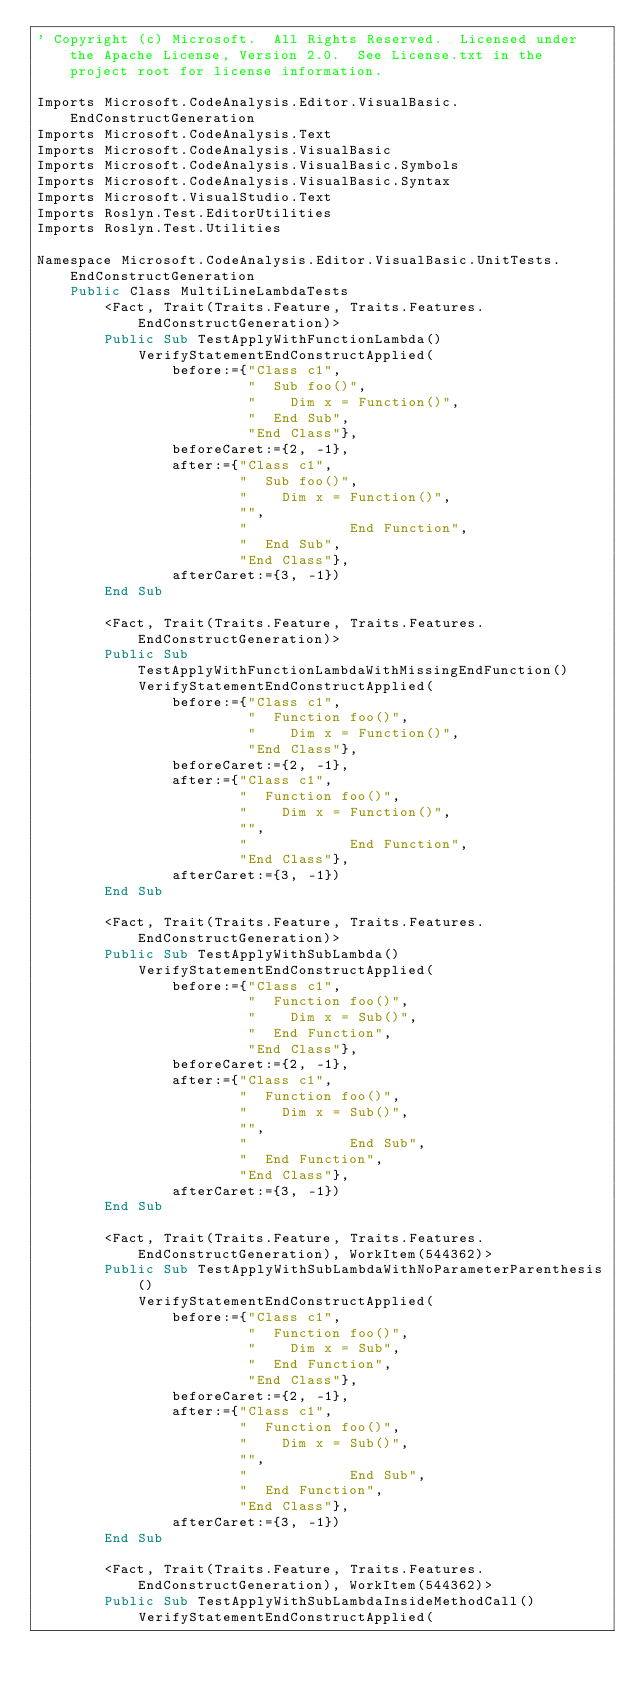<code> <loc_0><loc_0><loc_500><loc_500><_VisualBasic_>' Copyright (c) Microsoft.  All Rights Reserved.  Licensed under the Apache License, Version 2.0.  See License.txt in the project root for license information.

Imports Microsoft.CodeAnalysis.Editor.VisualBasic.EndConstructGeneration
Imports Microsoft.CodeAnalysis.Text
Imports Microsoft.CodeAnalysis.VisualBasic
Imports Microsoft.CodeAnalysis.VisualBasic.Symbols
Imports Microsoft.CodeAnalysis.VisualBasic.Syntax
Imports Microsoft.VisualStudio.Text
Imports Roslyn.Test.EditorUtilities
Imports Roslyn.Test.Utilities

Namespace Microsoft.CodeAnalysis.Editor.VisualBasic.UnitTests.EndConstructGeneration
    Public Class MultiLineLambdaTests
        <Fact, Trait(Traits.Feature, Traits.Features.EndConstructGeneration)>
        Public Sub TestApplyWithFunctionLambda()
            VerifyStatementEndConstructApplied(
                before:={"Class c1",
                         "  Sub foo()",
                         "    Dim x = Function()",
                         "  End Sub",
                         "End Class"},
                beforeCaret:={2, -1},
                after:={"Class c1",
                        "  Sub foo()",
                        "    Dim x = Function()",
                        "",
                        "            End Function",
                        "  End Sub",
                        "End Class"},
                afterCaret:={3, -1})
        End Sub

        <Fact, Trait(Traits.Feature, Traits.Features.EndConstructGeneration)>
        Public Sub TestApplyWithFunctionLambdaWithMissingEndFunction()
            VerifyStatementEndConstructApplied(
                before:={"Class c1",
                         "  Function foo()",
                         "    Dim x = Function()",
                         "End Class"},
                beforeCaret:={2, -1},
                after:={"Class c1",
                        "  Function foo()",
                        "    Dim x = Function()",
                        "",
                        "            End Function",
                        "End Class"},
                afterCaret:={3, -1})
        End Sub

        <Fact, Trait(Traits.Feature, Traits.Features.EndConstructGeneration)>
        Public Sub TestApplyWithSubLambda()
            VerifyStatementEndConstructApplied(
                before:={"Class c1",
                         "  Function foo()",
                         "    Dim x = Sub()",
                         "  End Function",
                         "End Class"},
                beforeCaret:={2, -1},
                after:={"Class c1",
                        "  Function foo()",
                        "    Dim x = Sub()",
                        "",
                        "            End Sub",
                        "  End Function",
                        "End Class"},
                afterCaret:={3, -1})
        End Sub

        <Fact, Trait(Traits.Feature, Traits.Features.EndConstructGeneration), WorkItem(544362)>
        Public Sub TestApplyWithSubLambdaWithNoParameterParenthesis()
            VerifyStatementEndConstructApplied(
                before:={"Class c1",
                         "  Function foo()",
                         "    Dim x = Sub",
                         "  End Function",
                         "End Class"},
                beforeCaret:={2, -1},
                after:={"Class c1",
                        "  Function foo()",
                        "    Dim x = Sub()",
                        "",
                        "            End Sub",
                        "  End Function",
                        "End Class"},
                afterCaret:={3, -1})
        End Sub

        <Fact, Trait(Traits.Feature, Traits.Features.EndConstructGeneration), WorkItem(544362)>
        Public Sub TestApplyWithSubLambdaInsideMethodCall()
            VerifyStatementEndConstructApplied(</code> 